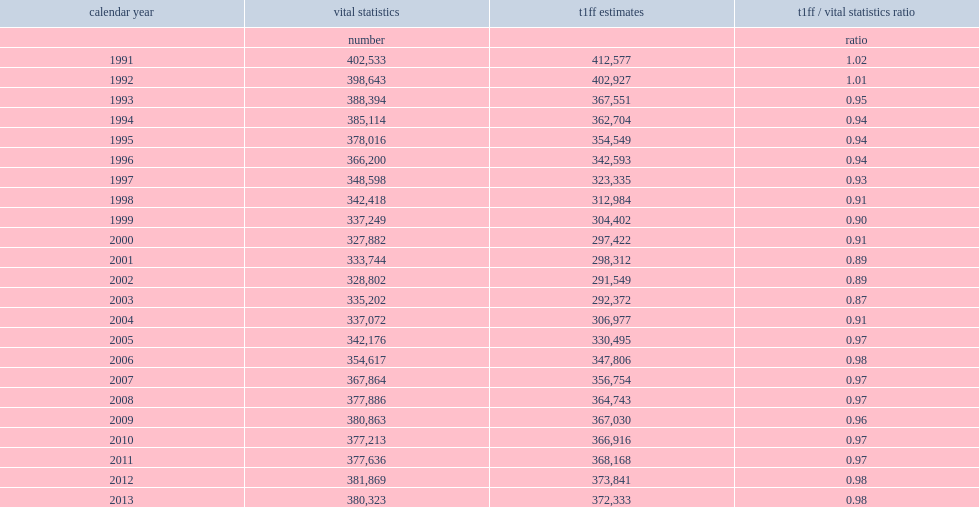What is the percentage that the number of newborns in the t1ff more than that in the vital statistics in 1991? 0.02. What is the percentage that the number of newborns in the t1ff more than that in the vital statistics in 1992? 0.01. 